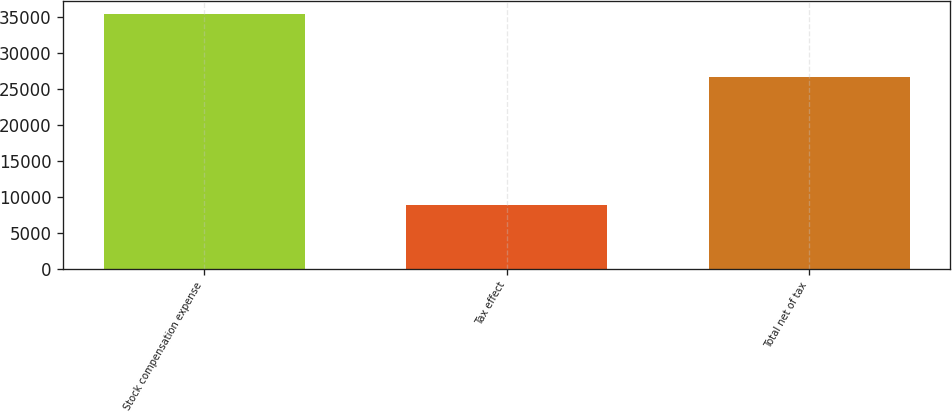<chart> <loc_0><loc_0><loc_500><loc_500><bar_chart><fcel>Stock compensation expense<fcel>Tax effect<fcel>Total net of tax<nl><fcel>35409<fcel>8825<fcel>26584<nl></chart> 